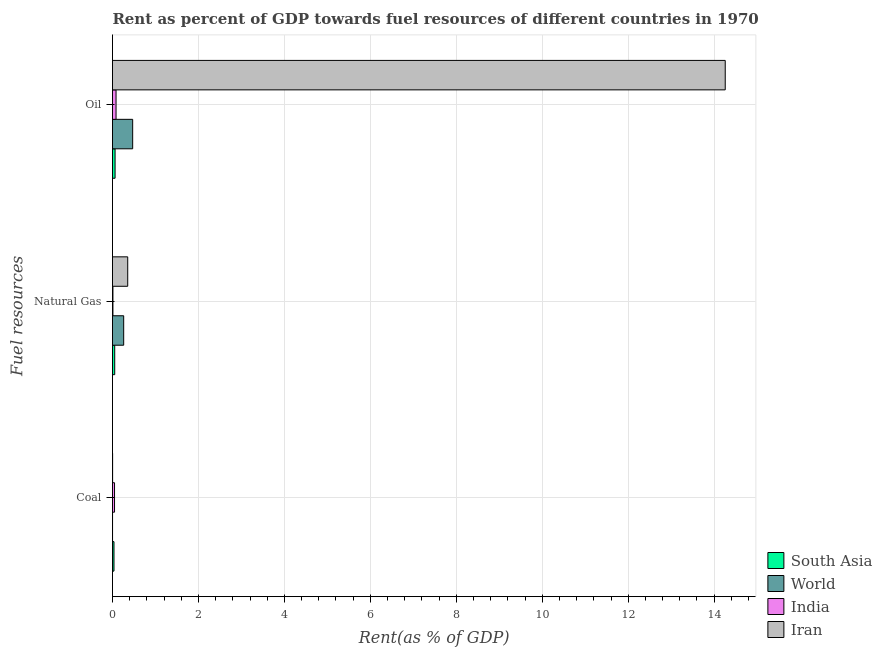How many groups of bars are there?
Offer a very short reply. 3. Are the number of bars per tick equal to the number of legend labels?
Make the answer very short. Yes. How many bars are there on the 2nd tick from the bottom?
Your answer should be compact. 4. What is the label of the 2nd group of bars from the top?
Offer a terse response. Natural Gas. What is the rent towards natural gas in India?
Provide a succinct answer. 0.01. Across all countries, what is the maximum rent towards coal?
Offer a terse response. 0.05. Across all countries, what is the minimum rent towards natural gas?
Your response must be concise. 0.01. In which country was the rent towards oil maximum?
Make the answer very short. Iran. In which country was the rent towards coal minimum?
Provide a short and direct response. World. What is the total rent towards coal in the graph?
Ensure brevity in your answer.  0.09. What is the difference between the rent towards coal in Iran and that in World?
Offer a terse response. 0. What is the difference between the rent towards natural gas in World and the rent towards coal in Iran?
Your answer should be very brief. 0.26. What is the average rent towards oil per country?
Offer a very short reply. 3.72. What is the difference between the rent towards coal and rent towards natural gas in India?
Give a very brief answer. 0.04. In how many countries, is the rent towards coal greater than 2 %?
Provide a short and direct response. 0. What is the ratio of the rent towards coal in South Asia to that in Iran?
Provide a succinct answer. 13.13. Is the rent towards oil in World less than that in Iran?
Your answer should be compact. Yes. What is the difference between the highest and the second highest rent towards coal?
Offer a very short reply. 0.01. What is the difference between the highest and the lowest rent towards oil?
Your answer should be very brief. 14.2. In how many countries, is the rent towards coal greater than the average rent towards coal taken over all countries?
Your answer should be very brief. 2. What does the 4th bar from the bottom in Oil represents?
Provide a succinct answer. Iran. Is it the case that in every country, the sum of the rent towards coal and rent towards natural gas is greater than the rent towards oil?
Provide a short and direct response. No. Are all the bars in the graph horizontal?
Ensure brevity in your answer.  Yes. How many countries are there in the graph?
Your answer should be very brief. 4. What is the difference between two consecutive major ticks on the X-axis?
Offer a terse response. 2. Does the graph contain grids?
Keep it short and to the point. Yes. How many legend labels are there?
Your answer should be compact. 4. What is the title of the graph?
Your response must be concise. Rent as percent of GDP towards fuel resources of different countries in 1970. Does "Jordan" appear as one of the legend labels in the graph?
Make the answer very short. No. What is the label or title of the X-axis?
Offer a terse response. Rent(as % of GDP). What is the label or title of the Y-axis?
Offer a terse response. Fuel resources. What is the Rent(as % of GDP) of South Asia in Coal?
Provide a succinct answer. 0.03. What is the Rent(as % of GDP) of World in Coal?
Provide a succinct answer. 0. What is the Rent(as % of GDP) in India in Coal?
Your answer should be compact. 0.05. What is the Rent(as % of GDP) in Iran in Coal?
Give a very brief answer. 0. What is the Rent(as % of GDP) of South Asia in Natural Gas?
Your answer should be compact. 0.05. What is the Rent(as % of GDP) in World in Natural Gas?
Give a very brief answer. 0.26. What is the Rent(as % of GDP) of India in Natural Gas?
Give a very brief answer. 0.01. What is the Rent(as % of GDP) in Iran in Natural Gas?
Provide a succinct answer. 0.35. What is the Rent(as % of GDP) of South Asia in Oil?
Keep it short and to the point. 0.06. What is the Rent(as % of GDP) in World in Oil?
Give a very brief answer. 0.47. What is the Rent(as % of GDP) of India in Oil?
Make the answer very short. 0.08. What is the Rent(as % of GDP) of Iran in Oil?
Ensure brevity in your answer.  14.26. Across all Fuel resources, what is the maximum Rent(as % of GDP) of South Asia?
Make the answer very short. 0.06. Across all Fuel resources, what is the maximum Rent(as % of GDP) in World?
Keep it short and to the point. 0.47. Across all Fuel resources, what is the maximum Rent(as % of GDP) of India?
Ensure brevity in your answer.  0.08. Across all Fuel resources, what is the maximum Rent(as % of GDP) in Iran?
Give a very brief answer. 14.26. Across all Fuel resources, what is the minimum Rent(as % of GDP) in South Asia?
Provide a succinct answer. 0.03. Across all Fuel resources, what is the minimum Rent(as % of GDP) of World?
Offer a terse response. 0. Across all Fuel resources, what is the minimum Rent(as % of GDP) in India?
Offer a very short reply. 0.01. Across all Fuel resources, what is the minimum Rent(as % of GDP) in Iran?
Your answer should be compact. 0. What is the total Rent(as % of GDP) in South Asia in the graph?
Ensure brevity in your answer.  0.15. What is the total Rent(as % of GDP) of World in the graph?
Offer a terse response. 0.73. What is the total Rent(as % of GDP) in India in the graph?
Give a very brief answer. 0.14. What is the total Rent(as % of GDP) of Iran in the graph?
Your response must be concise. 14.61. What is the difference between the Rent(as % of GDP) of South Asia in Coal and that in Natural Gas?
Provide a succinct answer. -0.02. What is the difference between the Rent(as % of GDP) of World in Coal and that in Natural Gas?
Ensure brevity in your answer.  -0.26. What is the difference between the Rent(as % of GDP) in India in Coal and that in Natural Gas?
Offer a very short reply. 0.04. What is the difference between the Rent(as % of GDP) of Iran in Coal and that in Natural Gas?
Your answer should be very brief. -0.35. What is the difference between the Rent(as % of GDP) of South Asia in Coal and that in Oil?
Ensure brevity in your answer.  -0.03. What is the difference between the Rent(as % of GDP) in World in Coal and that in Oil?
Your answer should be very brief. -0.47. What is the difference between the Rent(as % of GDP) of India in Coal and that in Oil?
Your response must be concise. -0.04. What is the difference between the Rent(as % of GDP) in Iran in Coal and that in Oil?
Provide a succinct answer. -14.25. What is the difference between the Rent(as % of GDP) of South Asia in Natural Gas and that in Oil?
Provide a succinct answer. -0.01. What is the difference between the Rent(as % of GDP) in World in Natural Gas and that in Oil?
Your answer should be compact. -0.21. What is the difference between the Rent(as % of GDP) of India in Natural Gas and that in Oil?
Keep it short and to the point. -0.07. What is the difference between the Rent(as % of GDP) in Iran in Natural Gas and that in Oil?
Make the answer very short. -13.9. What is the difference between the Rent(as % of GDP) in South Asia in Coal and the Rent(as % of GDP) in World in Natural Gas?
Your answer should be very brief. -0.23. What is the difference between the Rent(as % of GDP) of South Asia in Coal and the Rent(as % of GDP) of India in Natural Gas?
Your answer should be compact. 0.02. What is the difference between the Rent(as % of GDP) in South Asia in Coal and the Rent(as % of GDP) in Iran in Natural Gas?
Your answer should be compact. -0.32. What is the difference between the Rent(as % of GDP) in World in Coal and the Rent(as % of GDP) in India in Natural Gas?
Your response must be concise. -0.01. What is the difference between the Rent(as % of GDP) in World in Coal and the Rent(as % of GDP) in Iran in Natural Gas?
Offer a very short reply. -0.35. What is the difference between the Rent(as % of GDP) in India in Coal and the Rent(as % of GDP) in Iran in Natural Gas?
Your answer should be compact. -0.31. What is the difference between the Rent(as % of GDP) of South Asia in Coal and the Rent(as % of GDP) of World in Oil?
Keep it short and to the point. -0.43. What is the difference between the Rent(as % of GDP) in South Asia in Coal and the Rent(as % of GDP) in India in Oil?
Provide a short and direct response. -0.05. What is the difference between the Rent(as % of GDP) of South Asia in Coal and the Rent(as % of GDP) of Iran in Oil?
Your response must be concise. -14.22. What is the difference between the Rent(as % of GDP) in World in Coal and the Rent(as % of GDP) in India in Oil?
Offer a terse response. -0.08. What is the difference between the Rent(as % of GDP) of World in Coal and the Rent(as % of GDP) of Iran in Oil?
Offer a very short reply. -14.26. What is the difference between the Rent(as % of GDP) in India in Coal and the Rent(as % of GDP) in Iran in Oil?
Your answer should be compact. -14.21. What is the difference between the Rent(as % of GDP) in South Asia in Natural Gas and the Rent(as % of GDP) in World in Oil?
Your answer should be very brief. -0.42. What is the difference between the Rent(as % of GDP) in South Asia in Natural Gas and the Rent(as % of GDP) in India in Oil?
Keep it short and to the point. -0.03. What is the difference between the Rent(as % of GDP) in South Asia in Natural Gas and the Rent(as % of GDP) in Iran in Oil?
Your answer should be very brief. -14.21. What is the difference between the Rent(as % of GDP) of World in Natural Gas and the Rent(as % of GDP) of India in Oil?
Provide a short and direct response. 0.18. What is the difference between the Rent(as % of GDP) of World in Natural Gas and the Rent(as % of GDP) of Iran in Oil?
Make the answer very short. -14. What is the difference between the Rent(as % of GDP) in India in Natural Gas and the Rent(as % of GDP) in Iran in Oil?
Offer a terse response. -14.25. What is the average Rent(as % of GDP) in South Asia per Fuel resources?
Provide a succinct answer. 0.05. What is the average Rent(as % of GDP) in World per Fuel resources?
Your response must be concise. 0.24. What is the average Rent(as % of GDP) of India per Fuel resources?
Your response must be concise. 0.05. What is the average Rent(as % of GDP) in Iran per Fuel resources?
Offer a very short reply. 4.87. What is the difference between the Rent(as % of GDP) in South Asia and Rent(as % of GDP) in World in Coal?
Offer a terse response. 0.03. What is the difference between the Rent(as % of GDP) in South Asia and Rent(as % of GDP) in India in Coal?
Make the answer very short. -0.01. What is the difference between the Rent(as % of GDP) of South Asia and Rent(as % of GDP) of Iran in Coal?
Your answer should be compact. 0.03. What is the difference between the Rent(as % of GDP) of World and Rent(as % of GDP) of India in Coal?
Ensure brevity in your answer.  -0.05. What is the difference between the Rent(as % of GDP) in World and Rent(as % of GDP) in Iran in Coal?
Give a very brief answer. -0. What is the difference between the Rent(as % of GDP) of India and Rent(as % of GDP) of Iran in Coal?
Make the answer very short. 0.04. What is the difference between the Rent(as % of GDP) of South Asia and Rent(as % of GDP) of World in Natural Gas?
Offer a very short reply. -0.21. What is the difference between the Rent(as % of GDP) of South Asia and Rent(as % of GDP) of India in Natural Gas?
Your response must be concise. 0.04. What is the difference between the Rent(as % of GDP) of South Asia and Rent(as % of GDP) of Iran in Natural Gas?
Your answer should be very brief. -0.3. What is the difference between the Rent(as % of GDP) in World and Rent(as % of GDP) in India in Natural Gas?
Provide a succinct answer. 0.25. What is the difference between the Rent(as % of GDP) in World and Rent(as % of GDP) in Iran in Natural Gas?
Offer a very short reply. -0.09. What is the difference between the Rent(as % of GDP) in India and Rent(as % of GDP) in Iran in Natural Gas?
Your response must be concise. -0.34. What is the difference between the Rent(as % of GDP) of South Asia and Rent(as % of GDP) of World in Oil?
Offer a terse response. -0.41. What is the difference between the Rent(as % of GDP) in South Asia and Rent(as % of GDP) in India in Oil?
Your answer should be compact. -0.02. What is the difference between the Rent(as % of GDP) of South Asia and Rent(as % of GDP) of Iran in Oil?
Your answer should be very brief. -14.2. What is the difference between the Rent(as % of GDP) of World and Rent(as % of GDP) of India in Oil?
Offer a terse response. 0.39. What is the difference between the Rent(as % of GDP) in World and Rent(as % of GDP) in Iran in Oil?
Your answer should be compact. -13.79. What is the difference between the Rent(as % of GDP) in India and Rent(as % of GDP) in Iran in Oil?
Keep it short and to the point. -14.18. What is the ratio of the Rent(as % of GDP) of South Asia in Coal to that in Natural Gas?
Your answer should be compact. 0.67. What is the ratio of the Rent(as % of GDP) in World in Coal to that in Natural Gas?
Your response must be concise. 0. What is the ratio of the Rent(as % of GDP) in India in Coal to that in Natural Gas?
Offer a terse response. 4.68. What is the ratio of the Rent(as % of GDP) of Iran in Coal to that in Natural Gas?
Provide a succinct answer. 0.01. What is the ratio of the Rent(as % of GDP) of South Asia in Coal to that in Oil?
Provide a short and direct response. 0.57. What is the ratio of the Rent(as % of GDP) in World in Coal to that in Oil?
Your response must be concise. 0. What is the ratio of the Rent(as % of GDP) of India in Coal to that in Oil?
Make the answer very short. 0.57. What is the ratio of the Rent(as % of GDP) of Iran in Coal to that in Oil?
Ensure brevity in your answer.  0. What is the ratio of the Rent(as % of GDP) of South Asia in Natural Gas to that in Oil?
Offer a terse response. 0.86. What is the ratio of the Rent(as % of GDP) in World in Natural Gas to that in Oil?
Provide a succinct answer. 0.56. What is the ratio of the Rent(as % of GDP) in India in Natural Gas to that in Oil?
Your answer should be compact. 0.12. What is the ratio of the Rent(as % of GDP) of Iran in Natural Gas to that in Oil?
Keep it short and to the point. 0.02. What is the difference between the highest and the second highest Rent(as % of GDP) in South Asia?
Offer a terse response. 0.01. What is the difference between the highest and the second highest Rent(as % of GDP) in World?
Make the answer very short. 0.21. What is the difference between the highest and the second highest Rent(as % of GDP) in India?
Keep it short and to the point. 0.04. What is the difference between the highest and the second highest Rent(as % of GDP) in Iran?
Ensure brevity in your answer.  13.9. What is the difference between the highest and the lowest Rent(as % of GDP) of South Asia?
Your response must be concise. 0.03. What is the difference between the highest and the lowest Rent(as % of GDP) of World?
Ensure brevity in your answer.  0.47. What is the difference between the highest and the lowest Rent(as % of GDP) of India?
Ensure brevity in your answer.  0.07. What is the difference between the highest and the lowest Rent(as % of GDP) of Iran?
Offer a very short reply. 14.25. 